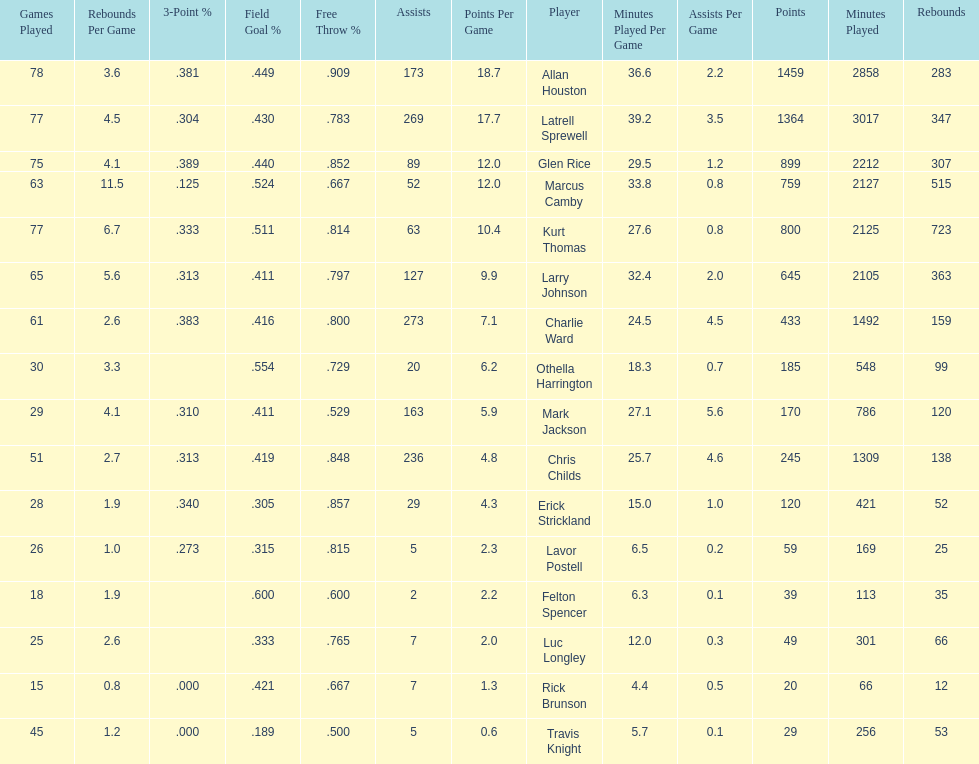Number of players on the team. 16. 